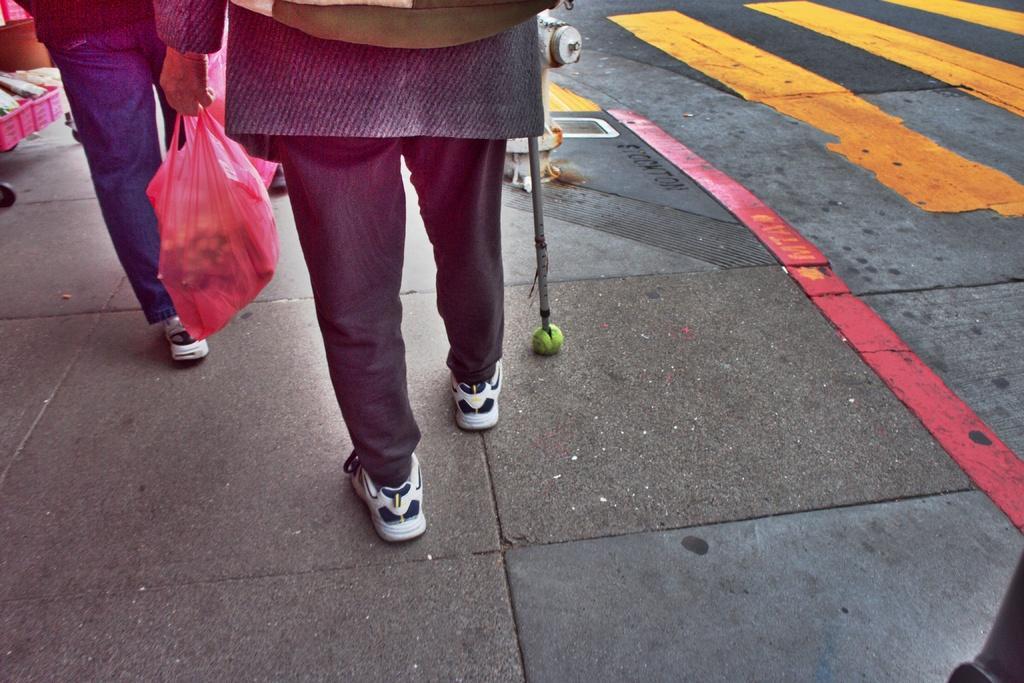How would you summarize this image in a sentence or two? This picture is taken on the road. In this image, on the left side, we can see a person holding a cover on one hand and the stick in the other hand. On the left side, we can also see a person walking. In the left corner, we can also see some baskets filled with some object. In the middle of the image, we can see a fire extinguisher. In the right corner, we can see an object. On the right side, we can see a road with yellow color and red color lights. 